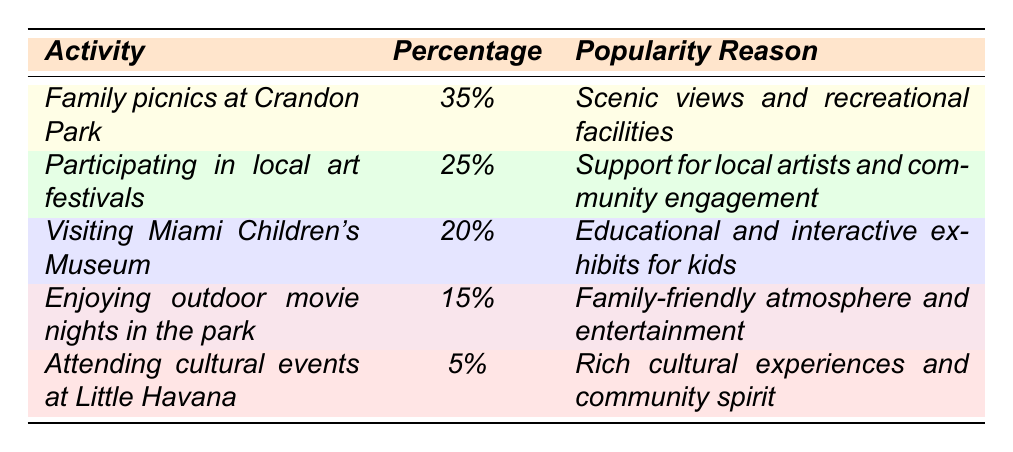What is the most popular family activity among Miami residents? The table shows that "Family picnics at Crandon Park" has the highest percentage at 35%.
Answer: 35% How many percentage points do "Participating in local art festivals" and "Visiting Miami Children's Museum" together account for? Adding the percentages for these two activities: 25% + 20% = 45%.
Answer: 45% Which activity has the lowest percentage? The table indicates that "Attending cultural events at Little Havana" has the lowest percentage at 5%.
Answer: 5% Is "Enjoying outdoor movie nights in the park" more popular than "Attending cultural events at Little Havana"? Yes, "Enjoying outdoor movie nights in the park" has 15%, which is greater than 5% for "Attending cultural events at Little Havana."
Answer: Yes What percentage of residents prefer activities that involve arts and culture (art festivals and cultural events)? Summing the percentages for art-related activities: 25% (art festivals) + 5% (cultural events) gives 30%.
Answer: 30% If you combine the percentages for activities involving education and fun for kids, what do you get? The activities are "Visiting Miami Children's Museum" (20%) and "Enjoying outdoor movie nights in the park" (15%). Adding these gives 20% + 15% = 35%.
Answer: 35% What is the percentage difference between the most and least popular activities? The most popular activity is 35% and the least popular is 5%. Therefore, the difference is 35% - 5% = 30%.
Answer: 30% Which activity is preferred more, outdoor movie nights or local art festivals? Comparing the two, outdoor movie nights have 15% while art festivals have 25%, indicating that art festivals are preferred more.
Answer: Local art festivals Calculate the total percentage of activities that are focused on family engagement. Activities such as picnics (35%), art festivals (25%), and outdoor movie nights (15%) focus on family. Summing these gives 35% + 25% + 15% = 75%.
Answer: 75% If 500 residents participated in the survey, how many prefer "Visiting Miami Children's Museum"? Since 20% prefer this activity, calculating gives 500 * 0.20 = 100 residents.
Answer: 100 